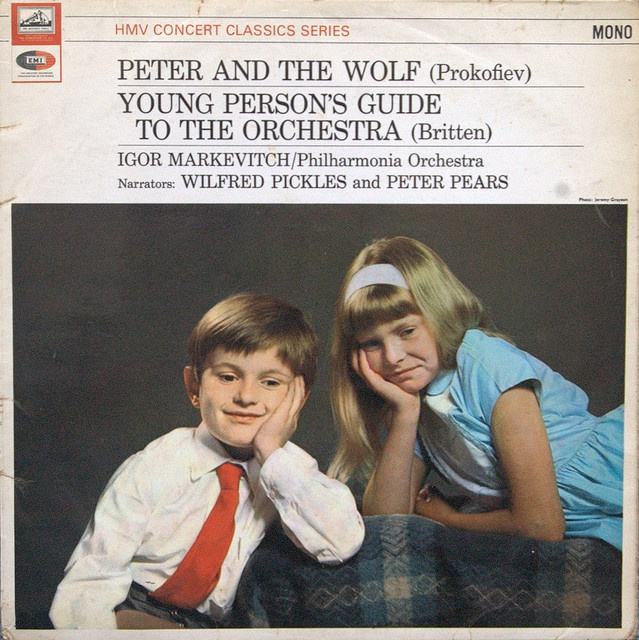Describe the objects in this image and their specific colors. I can see people in tan, gray, and maroon tones, people in tan, lightgray, gray, and black tones, and tie in tan, brown, red, and maroon tones in this image. 